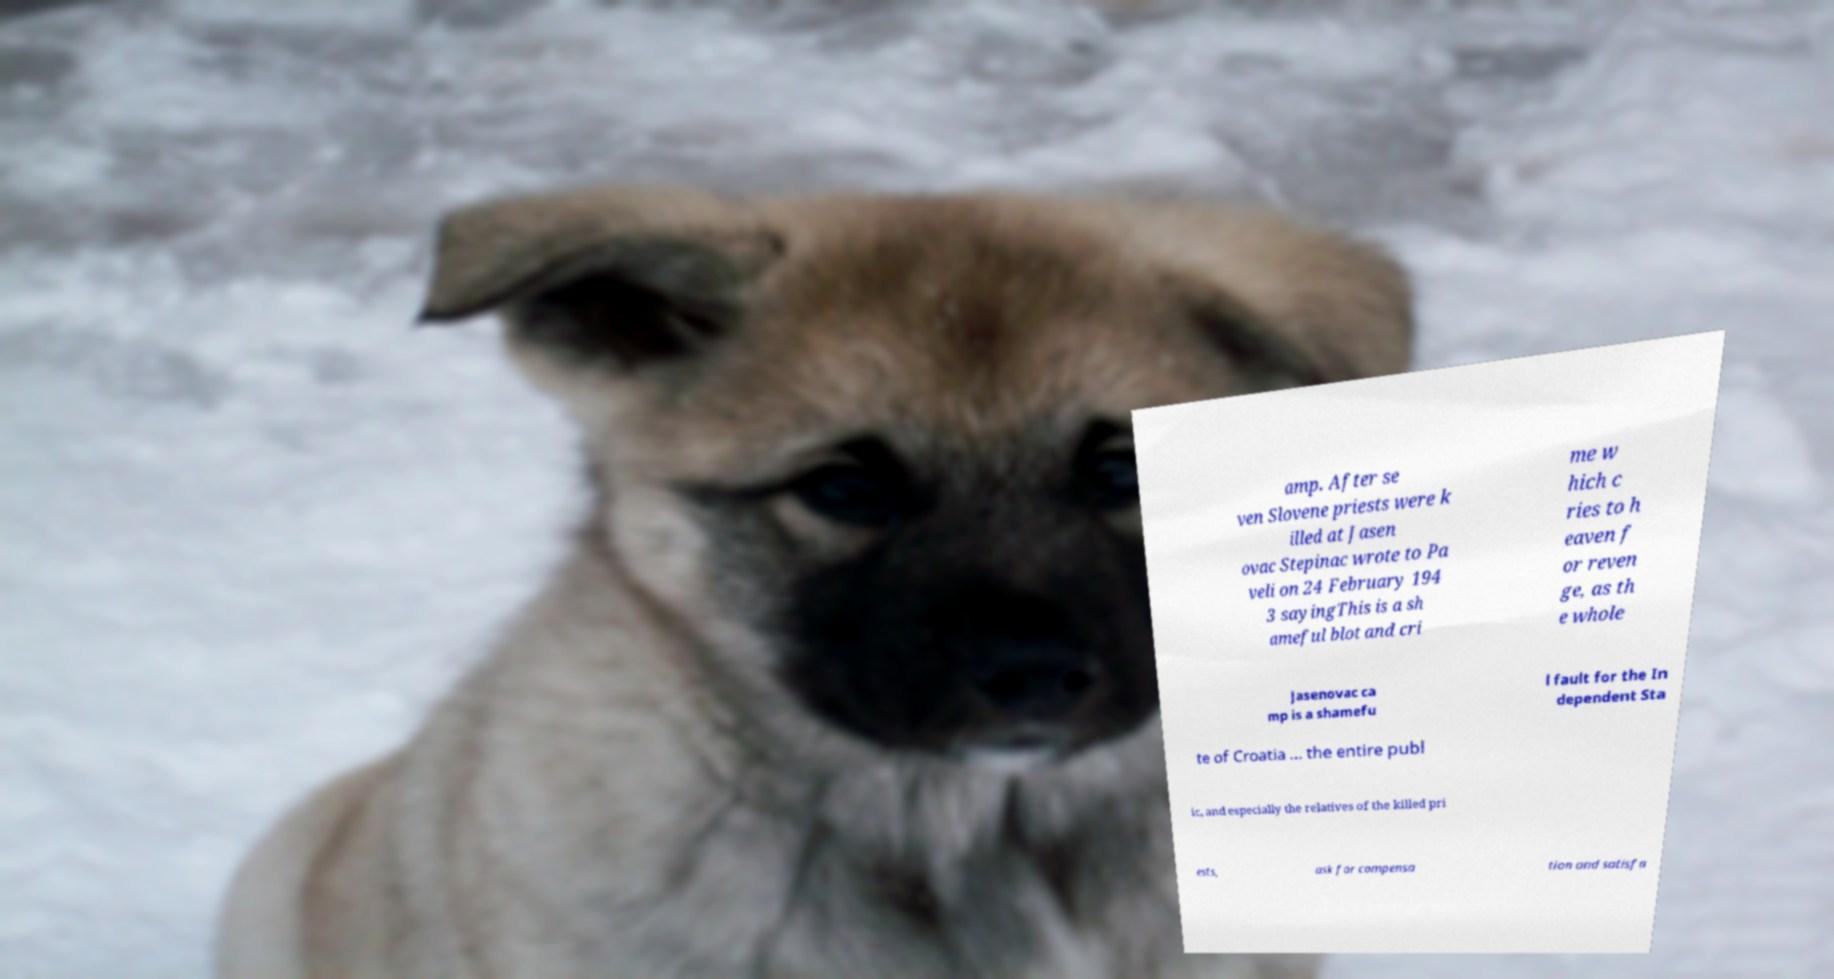There's text embedded in this image that I need extracted. Can you transcribe it verbatim? amp. After se ven Slovene priests were k illed at Jasen ovac Stepinac wrote to Pa veli on 24 February 194 3 sayingThis is a sh ameful blot and cri me w hich c ries to h eaven f or reven ge, as th e whole Jasenovac ca mp is a shamefu l fault for the In dependent Sta te of Croatia ... the entire publ ic, and especially the relatives of the killed pri ests, ask for compensa tion and satisfa 